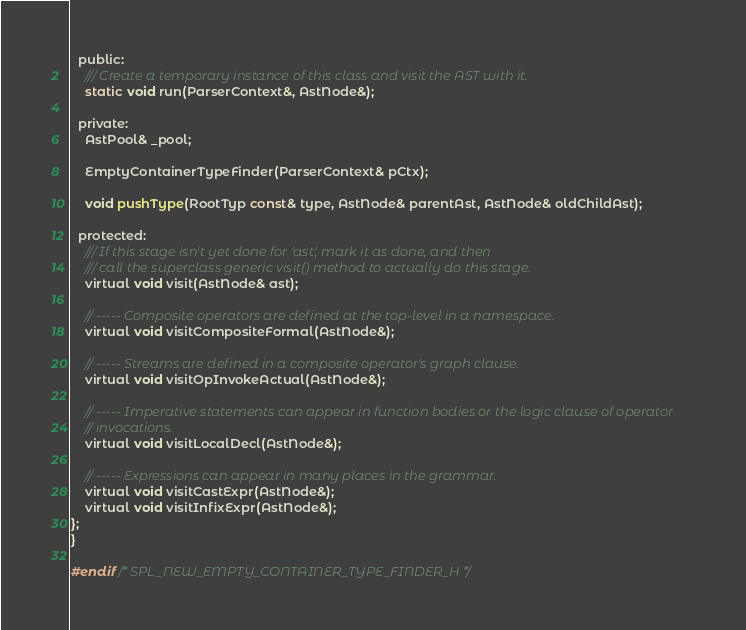Convert code to text. <code><loc_0><loc_0><loc_500><loc_500><_C_>  public:
    /// Create a temporary instance of this class and visit the AST with it.
    static void run(ParserContext&, AstNode&);

  private:
    AstPool& _pool;

    EmptyContainerTypeFinder(ParserContext& pCtx);

    void pushType(RootTyp const& type, AstNode& parentAst, AstNode& oldChildAst);

  protected:
    /// If this stage isn't yet done for 'ast', mark it as done, and then
    /// call the superclass generic visit() method to actually do this stage.
    virtual void visit(AstNode& ast);

    // ----- Composite operators are defined at the top-level in a namespace.
    virtual void visitCompositeFormal(AstNode&);

    // ----- Streams are defined in a composite operator's graph clause.
    virtual void visitOpInvokeActual(AstNode&);

    // ----- Imperative statements can appear in function bodies or the logic clause of operator
    // invocations.
    virtual void visitLocalDecl(AstNode&);

    // ----- Expressions can appear in many places in the grammar.
    virtual void visitCastExpr(AstNode&);
    virtual void visitInfixExpr(AstNode&);
};
}

#endif /* SPL_NEW_EMPTY_CONTAINER_TYPE_FINDER_H */
</code> 